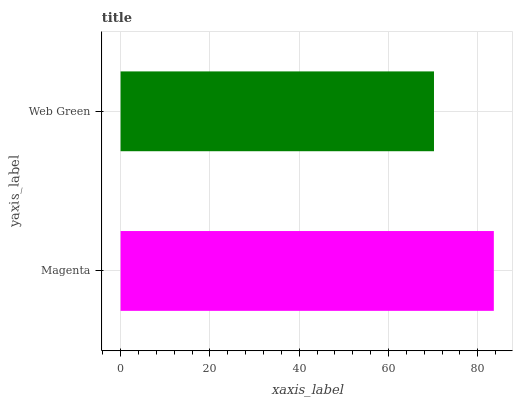Is Web Green the minimum?
Answer yes or no. Yes. Is Magenta the maximum?
Answer yes or no. Yes. Is Web Green the maximum?
Answer yes or no. No. Is Magenta greater than Web Green?
Answer yes or no. Yes. Is Web Green less than Magenta?
Answer yes or no. Yes. Is Web Green greater than Magenta?
Answer yes or no. No. Is Magenta less than Web Green?
Answer yes or no. No. Is Magenta the high median?
Answer yes or no. Yes. Is Web Green the low median?
Answer yes or no. Yes. Is Web Green the high median?
Answer yes or no. No. Is Magenta the low median?
Answer yes or no. No. 